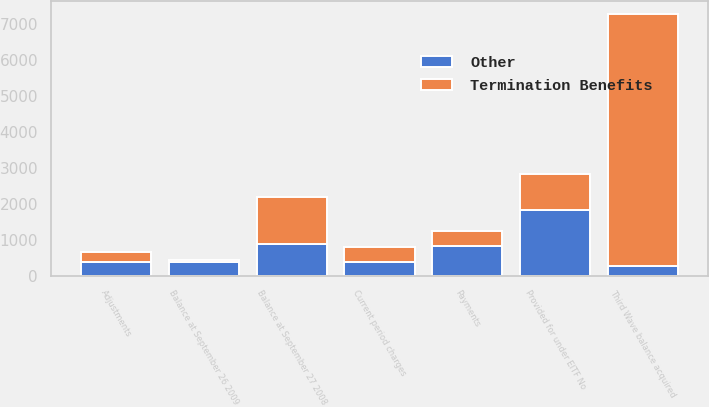Convert chart to OTSL. <chart><loc_0><loc_0><loc_500><loc_500><stacked_bar_chart><ecel><fcel>Third Wave balance acquired<fcel>Provided for under EITF No<fcel>Adjustments<fcel>Payments<fcel>Balance at September 27 2008<fcel>Current period charges<fcel>Balance at September 26 2009<nl><fcel>Other<fcel>261<fcel>1820<fcel>382<fcel>817<fcel>882<fcel>377<fcel>375<nl><fcel>Termination Benefits<fcel>7029<fcel>1020<fcel>270<fcel>420<fcel>1309<fcel>420<fcel>48<nl></chart> 